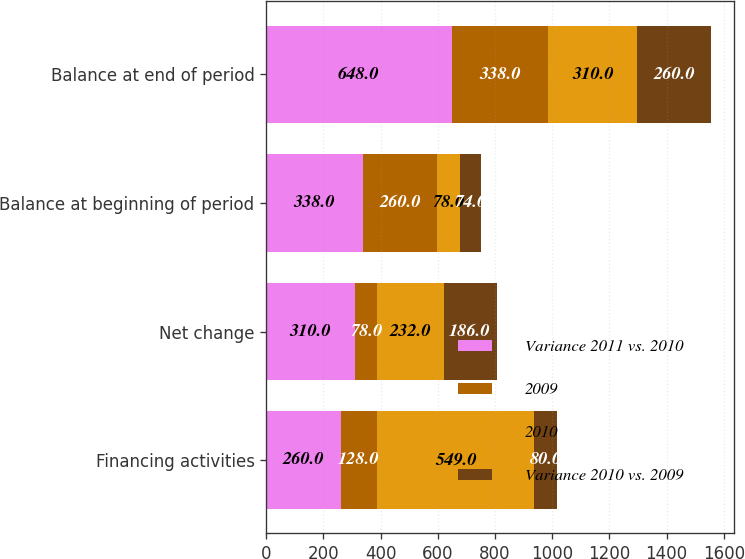<chart> <loc_0><loc_0><loc_500><loc_500><stacked_bar_chart><ecel><fcel>Financing activities<fcel>Net change<fcel>Balance at beginning of period<fcel>Balance at end of period<nl><fcel>Variance 2011 vs. 2010<fcel>260<fcel>310<fcel>338<fcel>648<nl><fcel>2009<fcel>128<fcel>78<fcel>260<fcel>338<nl><fcel>2010<fcel>549<fcel>232<fcel>78<fcel>310<nl><fcel>Variance 2010 vs. 2009<fcel>80<fcel>186<fcel>74<fcel>260<nl></chart> 